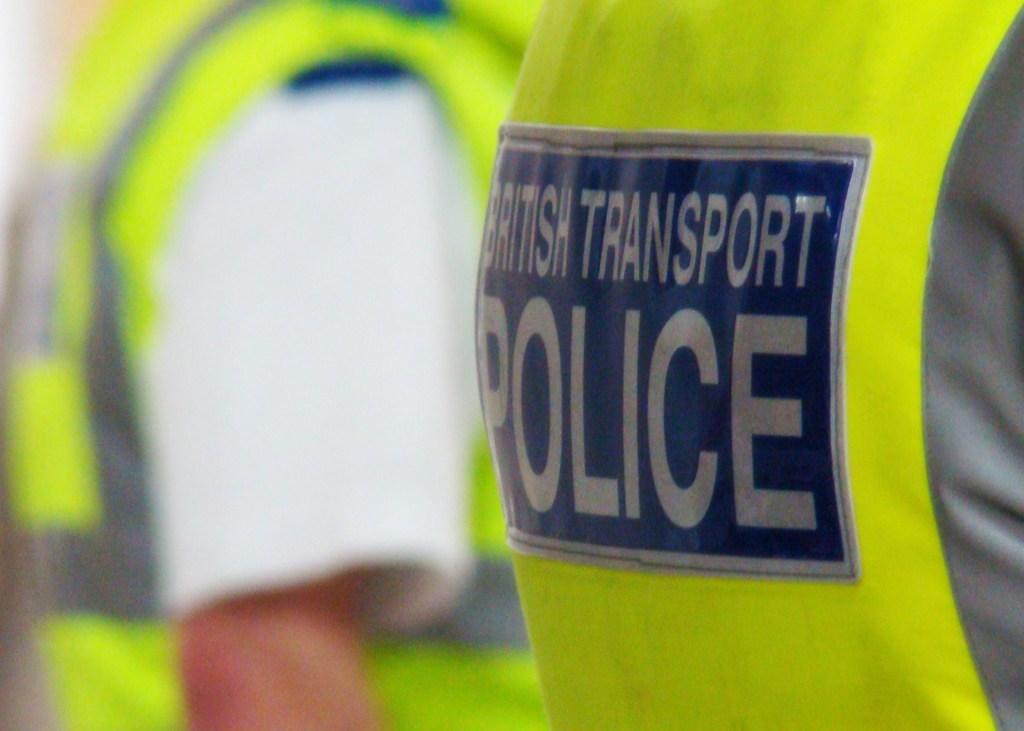Does the man in the yellow vest work for the police?
Your answer should be very brief. Yes. 